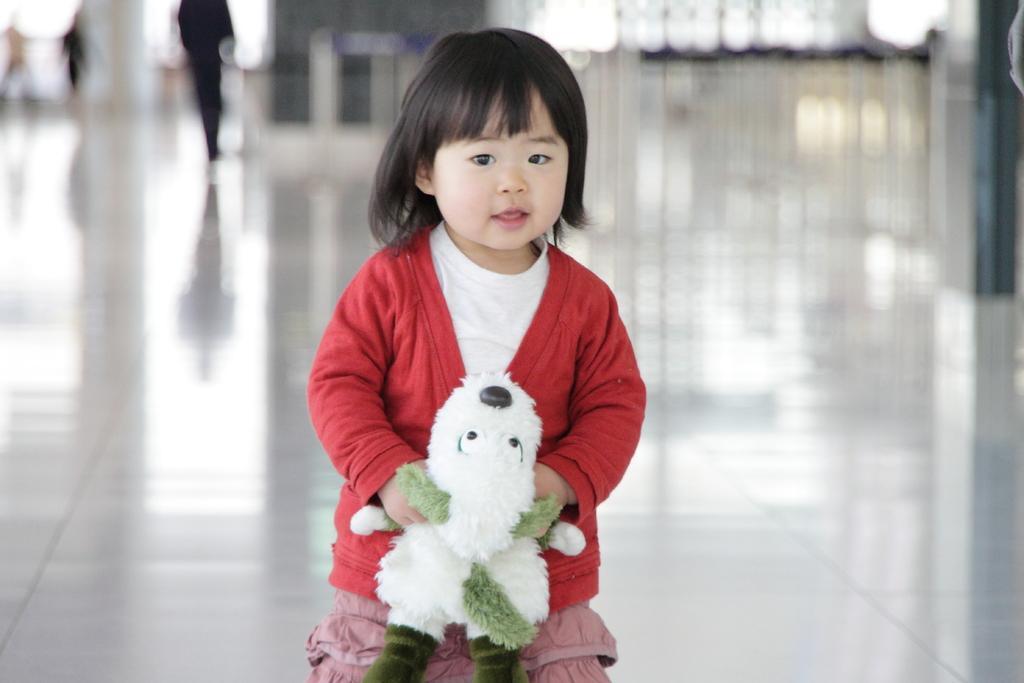Can you describe this image briefly? In this image I can see a girl is holding a soft toy in the hand. The background of the image is blurred. 